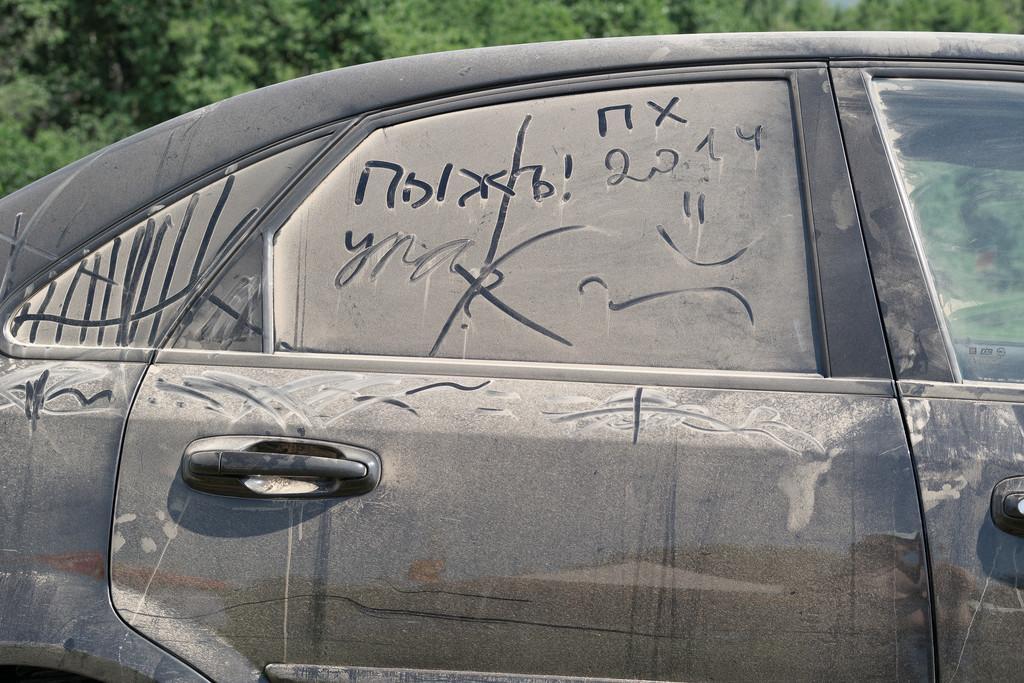Describe this image in one or two sentences. In this picture I can see in the middle there is a vehicle in black color, in the background there are trees. 